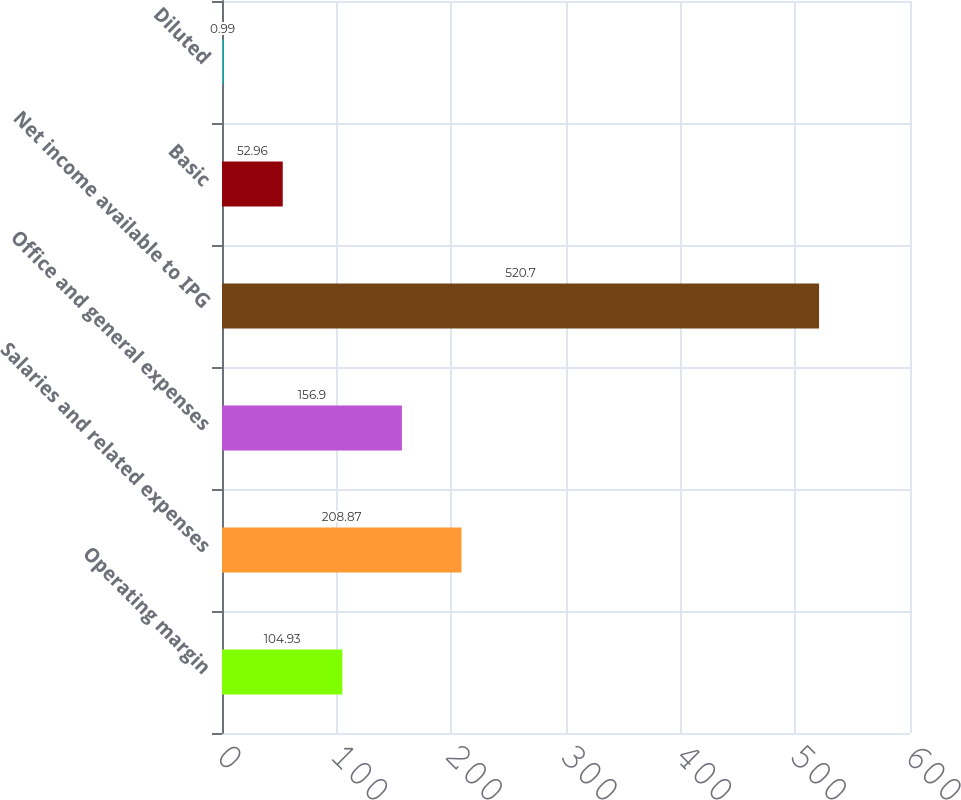Convert chart. <chart><loc_0><loc_0><loc_500><loc_500><bar_chart><fcel>Operating margin<fcel>Salaries and related expenses<fcel>Office and general expenses<fcel>Net income available to IPG<fcel>Basic<fcel>Diluted<nl><fcel>104.93<fcel>208.87<fcel>156.9<fcel>520.7<fcel>52.96<fcel>0.99<nl></chart> 